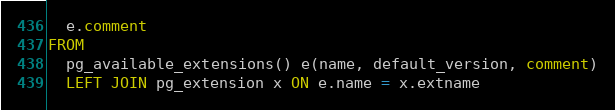<code> <loc_0><loc_0><loc_500><loc_500><_SQL_>  e.comment
FROM
  pg_available_extensions() e(name, default_version, comment)
  LEFT JOIN pg_extension x ON e.name = x.extname
</code> 